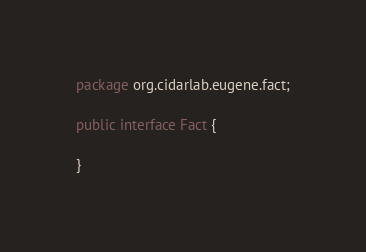<code> <loc_0><loc_0><loc_500><loc_500><_Java_>package org.cidarlab.eugene.fact;

public interface Fact {

}
</code> 